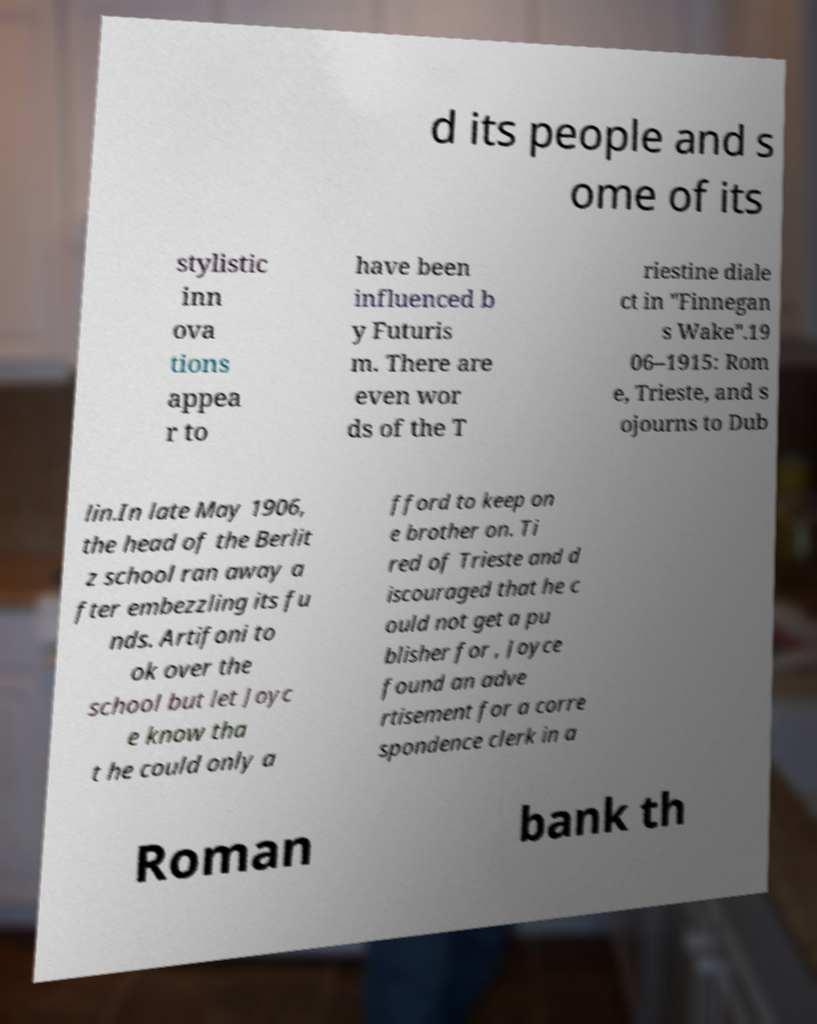Please read and relay the text visible in this image. What does it say? d its people and s ome of its stylistic inn ova tions appea r to have been influenced b y Futuris m. There are even wor ds of the T riestine diale ct in "Finnegan s Wake".19 06–1915: Rom e, Trieste, and s ojourns to Dub lin.In late May 1906, the head of the Berlit z school ran away a fter embezzling its fu nds. Artifoni to ok over the school but let Joyc e know tha t he could only a fford to keep on e brother on. Ti red of Trieste and d iscouraged that he c ould not get a pu blisher for , Joyce found an adve rtisement for a corre spondence clerk in a Roman bank th 